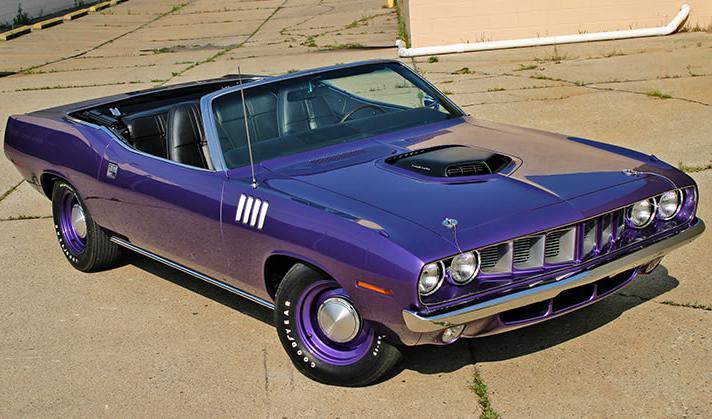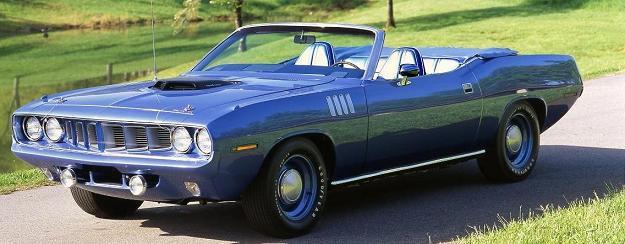The first image is the image on the left, the second image is the image on the right. Evaluate the accuracy of this statement regarding the images: "There are two cars that are the same color, but one has the top down while the other has its top up". Is it true? Answer yes or no. No. The first image is the image on the left, the second image is the image on the right. For the images shown, is this caption "The car in the image on the right is parked near the green grass." true? Answer yes or no. Yes. 